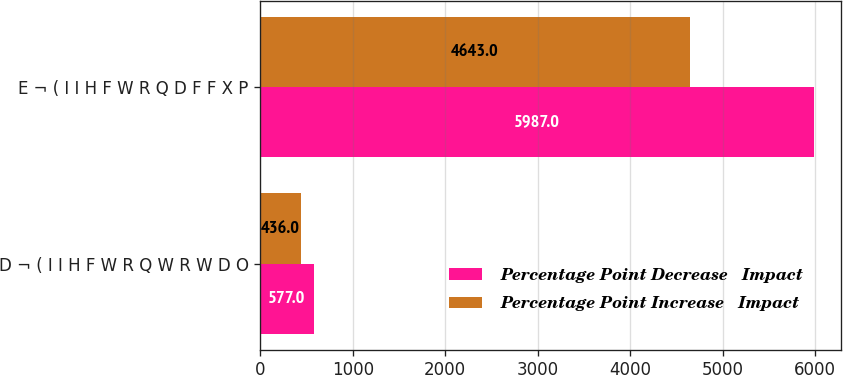Convert chart. <chart><loc_0><loc_0><loc_500><loc_500><stacked_bar_chart><ecel><fcel>D ¬ ( I I H F W R Q W R W D O<fcel>E ¬ ( I I H F W R Q D F F X P<nl><fcel>Percentage Point Decrease   Impact<fcel>577<fcel>5987<nl><fcel>Percentage Point Increase   Impact<fcel>436<fcel>4643<nl></chart> 